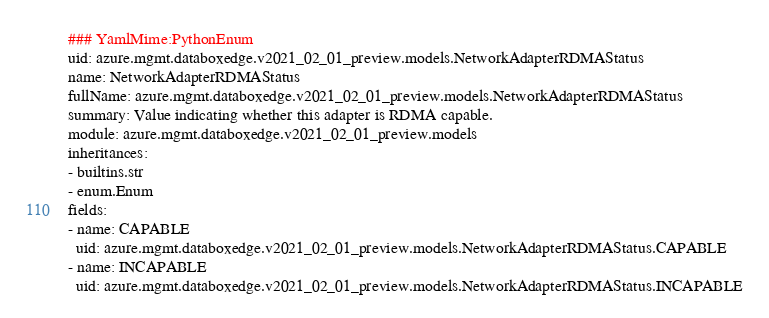Convert code to text. <code><loc_0><loc_0><loc_500><loc_500><_YAML_>### YamlMime:PythonEnum
uid: azure.mgmt.databoxedge.v2021_02_01_preview.models.NetworkAdapterRDMAStatus
name: NetworkAdapterRDMAStatus
fullName: azure.mgmt.databoxedge.v2021_02_01_preview.models.NetworkAdapterRDMAStatus
summary: Value indicating whether this adapter is RDMA capable.
module: azure.mgmt.databoxedge.v2021_02_01_preview.models
inheritances:
- builtins.str
- enum.Enum
fields:
- name: CAPABLE
  uid: azure.mgmt.databoxedge.v2021_02_01_preview.models.NetworkAdapterRDMAStatus.CAPABLE
- name: INCAPABLE
  uid: azure.mgmt.databoxedge.v2021_02_01_preview.models.NetworkAdapterRDMAStatus.INCAPABLE
</code> 